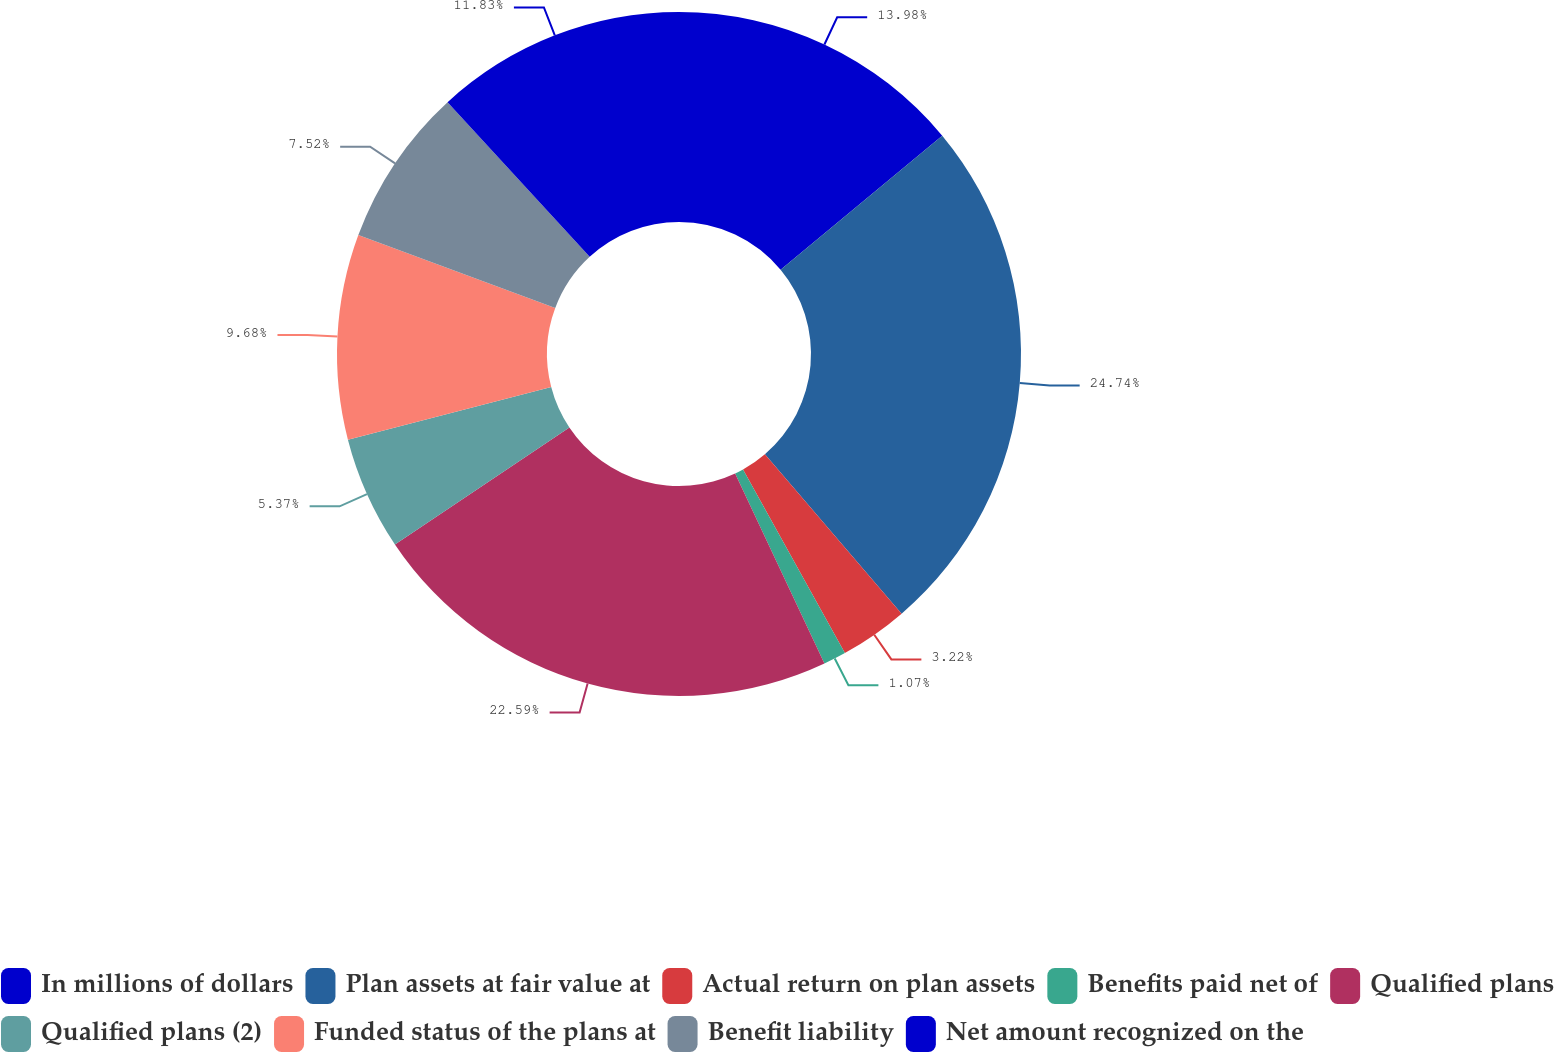Convert chart to OTSL. <chart><loc_0><loc_0><loc_500><loc_500><pie_chart><fcel>In millions of dollars<fcel>Plan assets at fair value at<fcel>Actual return on plan assets<fcel>Benefits paid net of<fcel>Qualified plans<fcel>Qualified plans (2)<fcel>Funded status of the plans at<fcel>Benefit liability<fcel>Net amount recognized on the<nl><fcel>13.98%<fcel>24.74%<fcel>3.22%<fcel>1.07%<fcel>22.59%<fcel>5.37%<fcel>9.68%<fcel>7.52%<fcel>11.83%<nl></chart> 